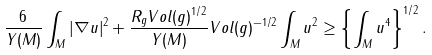Convert formula to latex. <formula><loc_0><loc_0><loc_500><loc_500>\frac { 6 } { Y ( M ) } \int _ { M } | \nabla u | ^ { 2 } + \frac { R _ { g } V o l ( g ) ^ { 1 / 2 } } { Y ( M ) } V o l ( g ) ^ { - 1 / 2 } \int _ { M } u ^ { 2 } \geq \left \{ \int _ { M } u ^ { 4 } \right \} ^ { 1 / 2 } .</formula> 